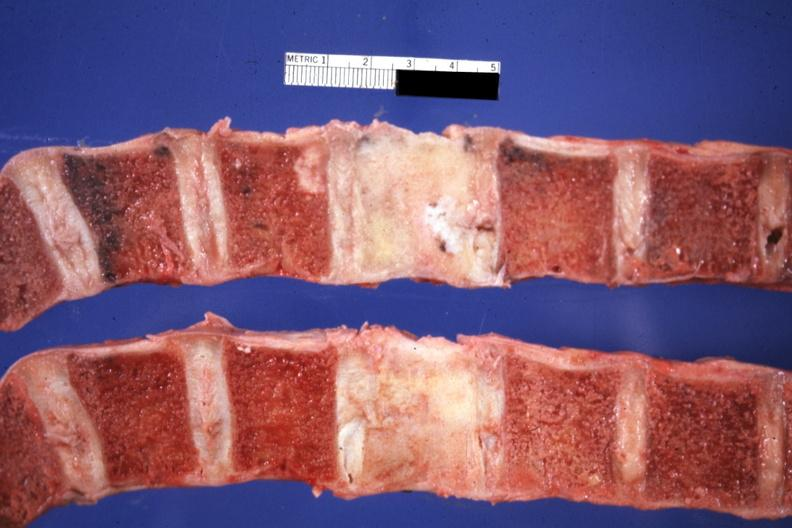what does this image show?
Answer the question using a single word or phrase. Sectioned typical primary is breast i think 